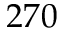<formula> <loc_0><loc_0><loc_500><loc_500>2 7 0</formula> 